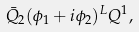Convert formula to latex. <formula><loc_0><loc_0><loc_500><loc_500>\bar { Q } _ { 2 } ( \phi _ { 1 } + i \phi _ { 2 } ) ^ { L } Q ^ { 1 } ,</formula> 